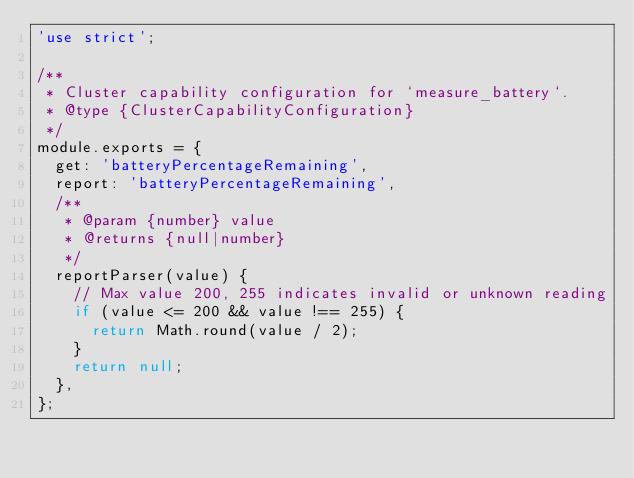Convert code to text. <code><loc_0><loc_0><loc_500><loc_500><_JavaScript_>'use strict';

/**
 * Cluster capability configuration for `measure_battery`.
 * @type {ClusterCapabilityConfiguration}
 */
module.exports = {
  get: 'batteryPercentageRemaining',
  report: 'batteryPercentageRemaining',
  /**
   * @param {number} value
   * @returns {null|number}
   */
  reportParser(value) {
    // Max value 200, 255 indicates invalid or unknown reading
    if (value <= 200 && value !== 255) {
      return Math.round(value / 2);
    }
    return null;
  },
};
</code> 